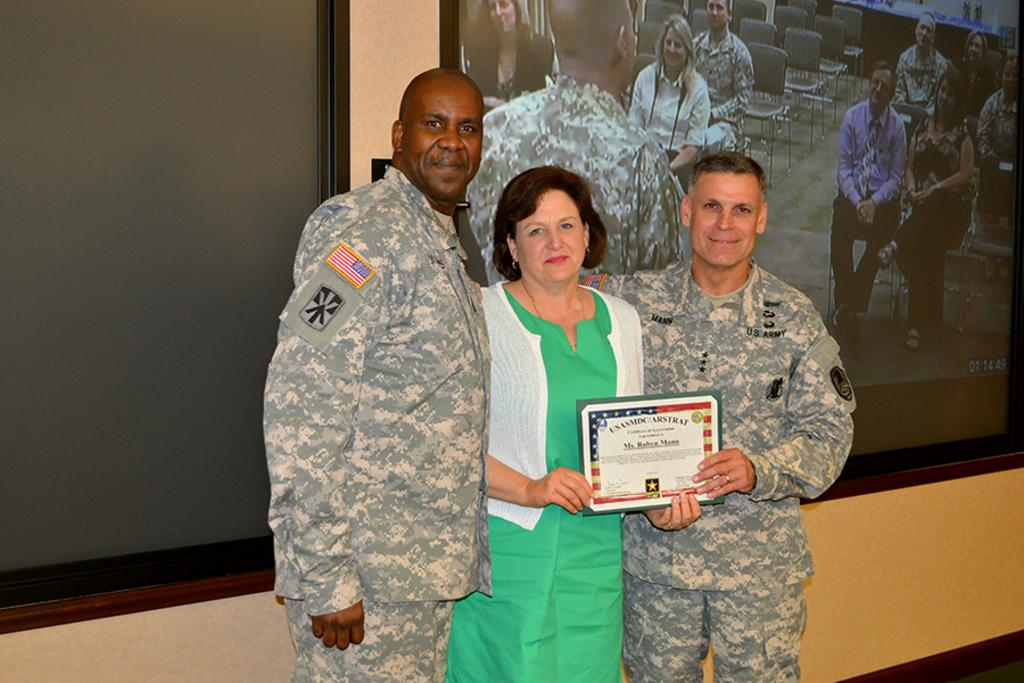How many people are in the image? There are persons standing in the image. What are the persons holding in the image? The persons are holding a certificate. What can be seen on the wall in the background of the image? There is a projector display on the wall. Are the persons holding hot bananas in the image? There is no mention of bananas, hot or otherwise, in the image. The persons are holding a certificate. 